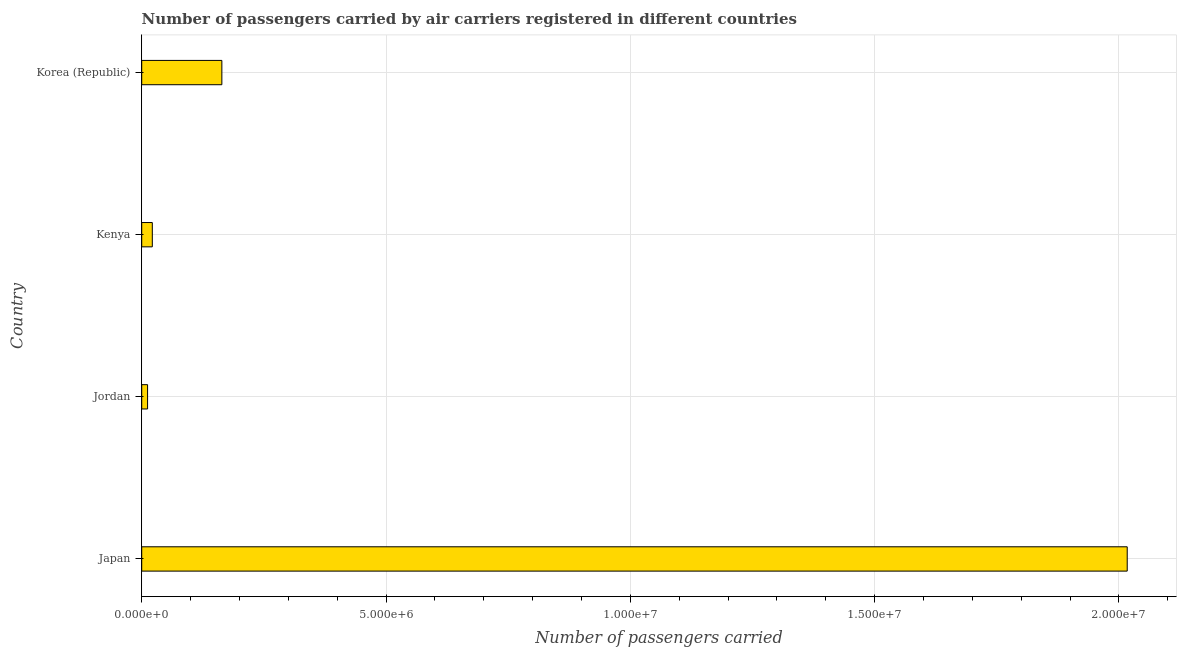Does the graph contain any zero values?
Make the answer very short. No. What is the title of the graph?
Provide a short and direct response. Number of passengers carried by air carriers registered in different countries. What is the label or title of the X-axis?
Provide a succinct answer. Number of passengers carried. What is the number of passengers carried in Jordan?
Offer a terse response. 1.20e+05. Across all countries, what is the maximum number of passengers carried?
Your response must be concise. 2.02e+07. Across all countries, what is the minimum number of passengers carried?
Ensure brevity in your answer.  1.20e+05. In which country was the number of passengers carried maximum?
Ensure brevity in your answer.  Japan. In which country was the number of passengers carried minimum?
Give a very brief answer. Jordan. What is the sum of the number of passengers carried?
Provide a succinct answer. 2.21e+07. What is the difference between the number of passengers carried in Japan and Korea (Republic)?
Give a very brief answer. 1.85e+07. What is the average number of passengers carried per country?
Give a very brief answer. 5.54e+06. What is the median number of passengers carried?
Give a very brief answer. 9.28e+05. In how many countries, is the number of passengers carried greater than 6000000 ?
Your response must be concise. 1. What is the ratio of the number of passengers carried in Kenya to that in Korea (Republic)?
Make the answer very short. 0.13. Is the number of passengers carried in Jordan less than that in Korea (Republic)?
Offer a terse response. Yes. What is the difference between the highest and the second highest number of passengers carried?
Your response must be concise. 1.85e+07. What is the difference between the highest and the lowest number of passengers carried?
Offer a terse response. 2.00e+07. How many bars are there?
Your response must be concise. 4. How many countries are there in the graph?
Provide a succinct answer. 4. What is the Number of passengers carried in Japan?
Your answer should be very brief. 2.02e+07. What is the Number of passengers carried in Jordan?
Offer a terse response. 1.20e+05. What is the Number of passengers carried in Kenya?
Ensure brevity in your answer.  2.17e+05. What is the Number of passengers carried in Korea (Republic)?
Your response must be concise. 1.64e+06. What is the difference between the Number of passengers carried in Japan and Jordan?
Offer a very short reply. 2.00e+07. What is the difference between the Number of passengers carried in Japan and Kenya?
Ensure brevity in your answer.  2.00e+07. What is the difference between the Number of passengers carried in Japan and Korea (Republic)?
Give a very brief answer. 1.85e+07. What is the difference between the Number of passengers carried in Jordan and Kenya?
Ensure brevity in your answer.  -9.69e+04. What is the difference between the Number of passengers carried in Jordan and Korea (Republic)?
Your response must be concise. -1.52e+06. What is the difference between the Number of passengers carried in Kenya and Korea (Republic)?
Ensure brevity in your answer.  -1.42e+06. What is the ratio of the Number of passengers carried in Japan to that in Jordan?
Ensure brevity in your answer.  168.22. What is the ratio of the Number of passengers carried in Japan to that in Kenya?
Your response must be concise. 93.03. What is the ratio of the Number of passengers carried in Japan to that in Korea (Republic)?
Provide a succinct answer. 12.3. What is the ratio of the Number of passengers carried in Jordan to that in Kenya?
Make the answer very short. 0.55. What is the ratio of the Number of passengers carried in Jordan to that in Korea (Republic)?
Offer a very short reply. 0.07. What is the ratio of the Number of passengers carried in Kenya to that in Korea (Republic)?
Give a very brief answer. 0.13. 